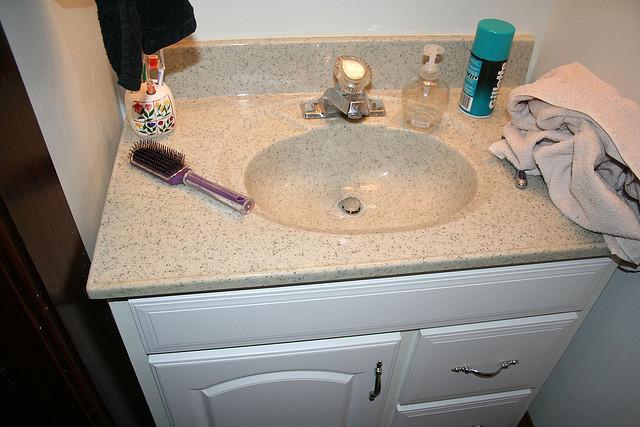What is in the clear bottle next to the faucet?
Concise answer only. Soap. What is the purpose of the prickly item on the left?
Answer briefly. Brush hair. What brand of shaving cream is on the counter?
Write a very short answer. Gillette. 